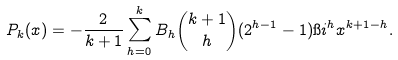<formula> <loc_0><loc_0><loc_500><loc_500>P _ { k } ( x ) = - \frac { 2 } { k + 1 } \sum _ { h = 0 } ^ { k } B _ { h } \binom { k + 1 } { h } ( 2 ^ { h - 1 } - 1 ) \i i ^ { h } x ^ { k + 1 - h } .</formula> 